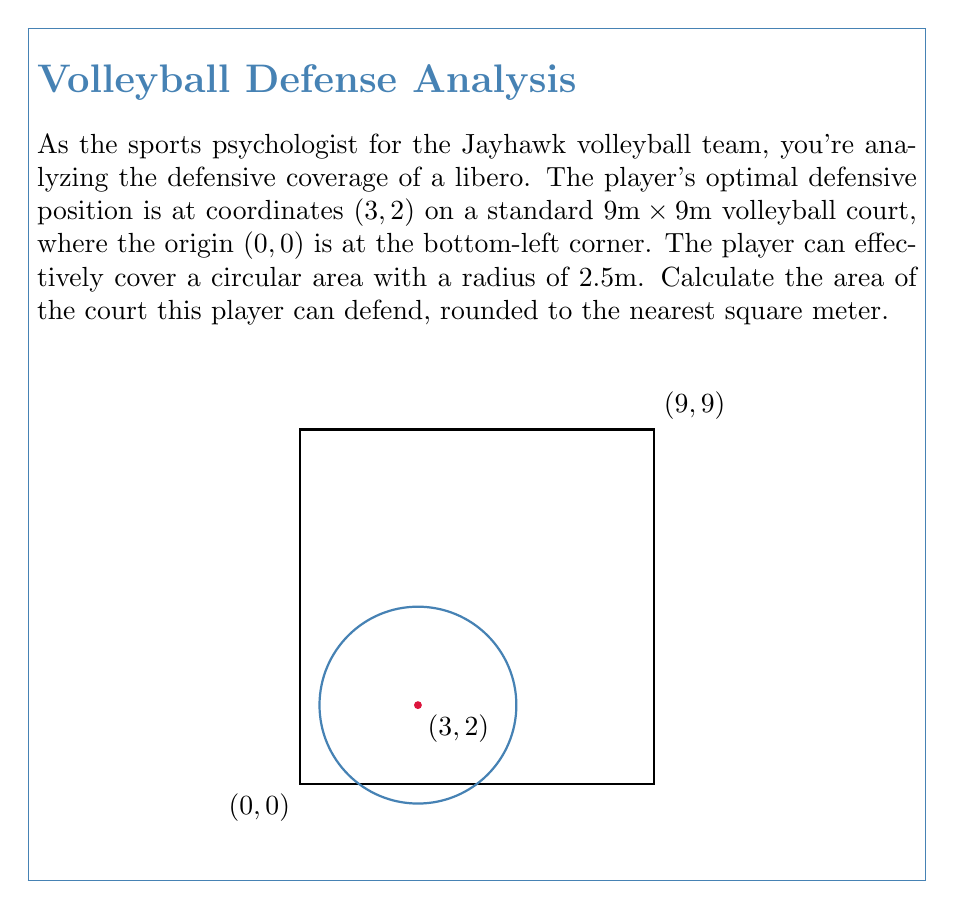Help me with this question. Let's approach this step-by-step:

1) The area of coverage for the player is circular, so we need to use the formula for the area of a circle:

   $$A = \pi r^2$$

   where $A$ is the area and $r$ is the radius.

2) We're given that the radius of coverage is 2.5m. Let's substitute this into our formula:

   $$A = \pi (2.5)^2$$

3) Let's calculate this:
   
   $$A = \pi (6.25) = 19.6349... m^2$$

4) The question asks for the answer rounded to the nearest square meter. 19.6349... rounds to 20.

Note: The player's position at (3, 2) doesn't affect the calculation of the area. It would only be relevant if we needed to determine how much of this circle falls within the court boundaries, which isn't asked in this question.
Answer: 20 m² 